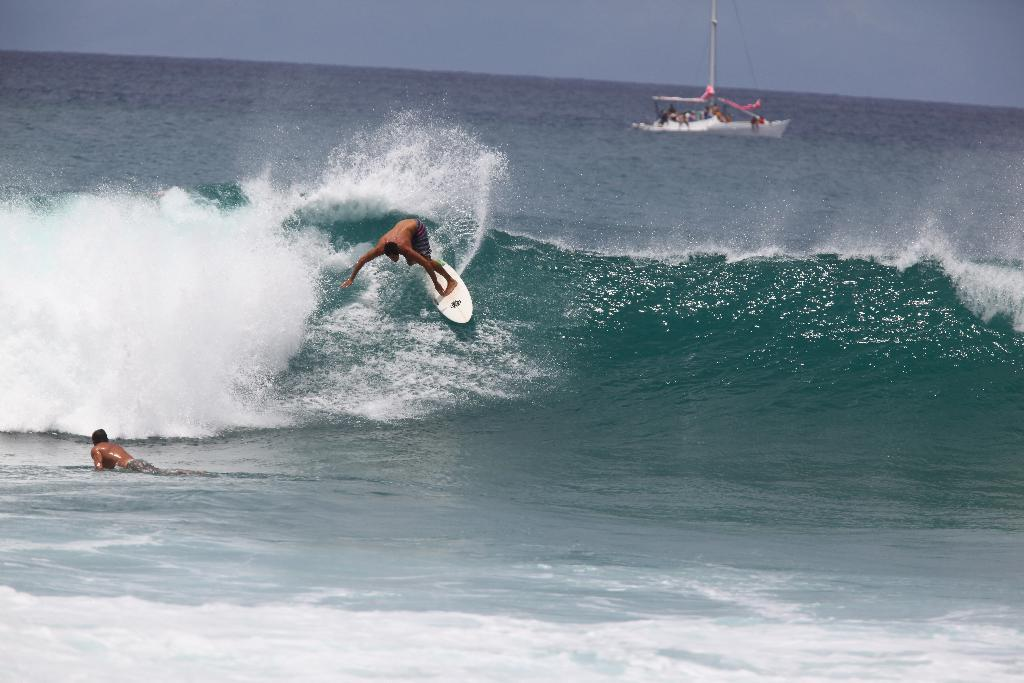What is the main subject of the image? The main subject of the image is an ocean. What are the two persons in the image doing? The two persons are surfing in the ocean. What can be seen in the background of the image? There is a boat in the background. What is visible at the top of the image? The sky is visible at the top of the image. What color is the surfboard? The surfboard is in white color. What is the price of the men's surfing equipment in the image? There is no information about the price of the surfing equipment in the image. Additionally, the question refers to "men," which is not mentioned in the facts provided. 